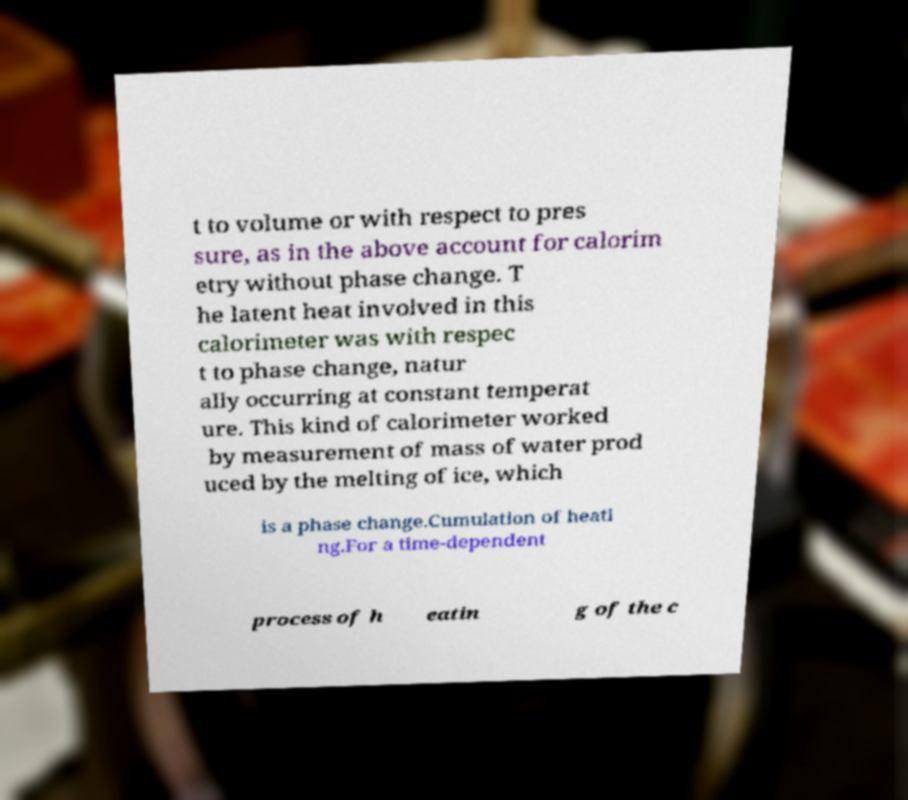Can you accurately transcribe the text from the provided image for me? t to volume or with respect to pres sure, as in the above account for calorim etry without phase change. T he latent heat involved in this calorimeter was with respec t to phase change, natur ally occurring at constant temperat ure. This kind of calorimeter worked by measurement of mass of water prod uced by the melting of ice, which is a phase change.Cumulation of heati ng.For a time-dependent process of h eatin g of the c 